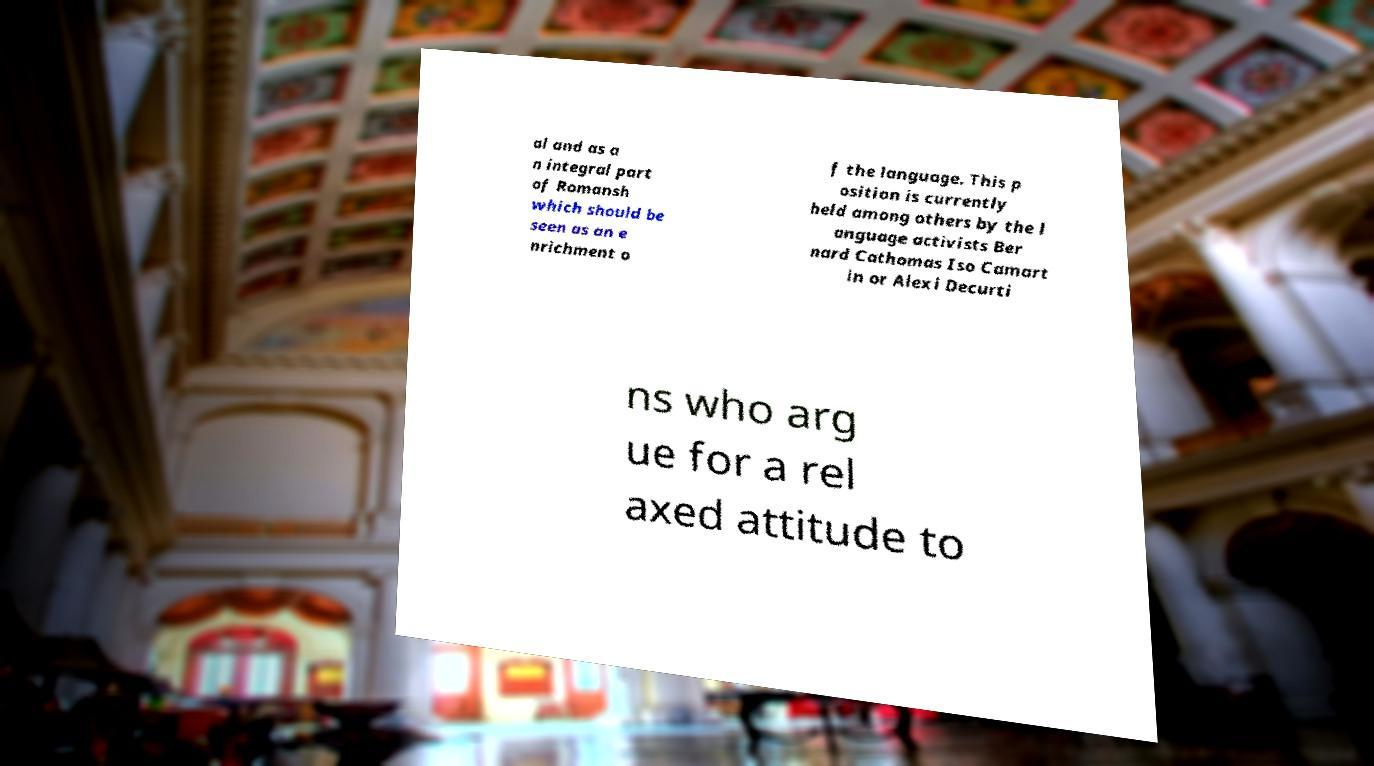I need the written content from this picture converted into text. Can you do that? al and as a n integral part of Romansh which should be seen as an e nrichment o f the language. This p osition is currently held among others by the l anguage activists Ber nard Cathomas Iso Camart in or Alexi Decurti ns who arg ue for a rel axed attitude to 